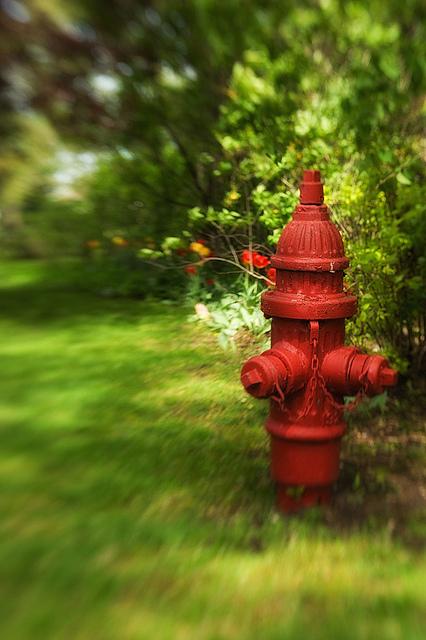What color is the fire hydrant on the right?
Answer briefly. Red. Is there grass in the picture?
Be succinct. Yes. How many plugs does the hydrant have?
Answer briefly. 2. 